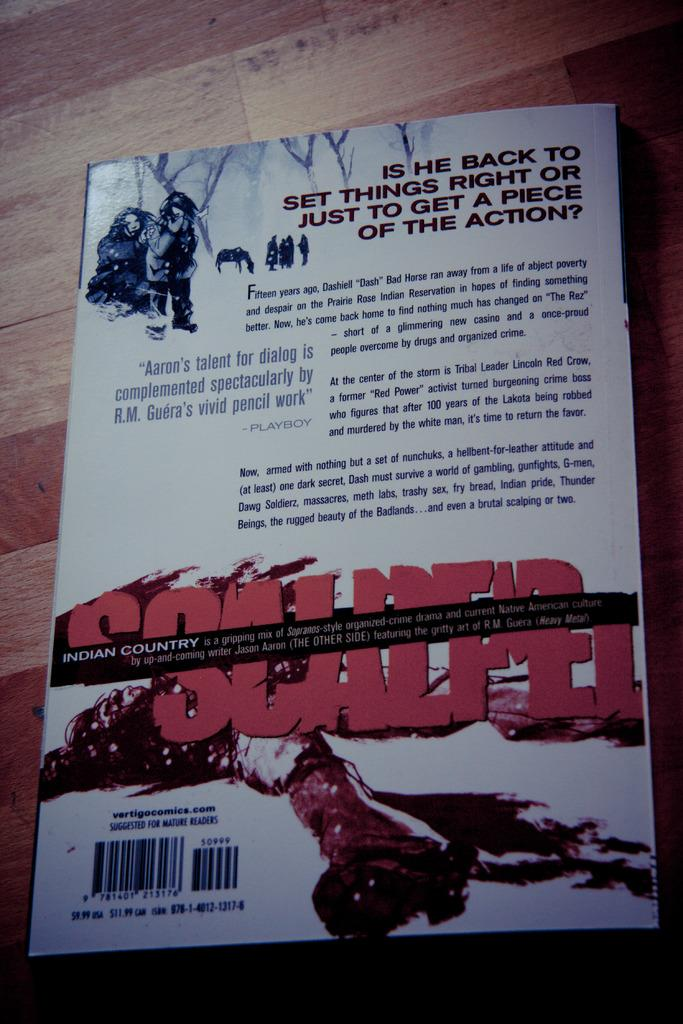<image>
Describe the image concisely. a book with the name Indian country on it 